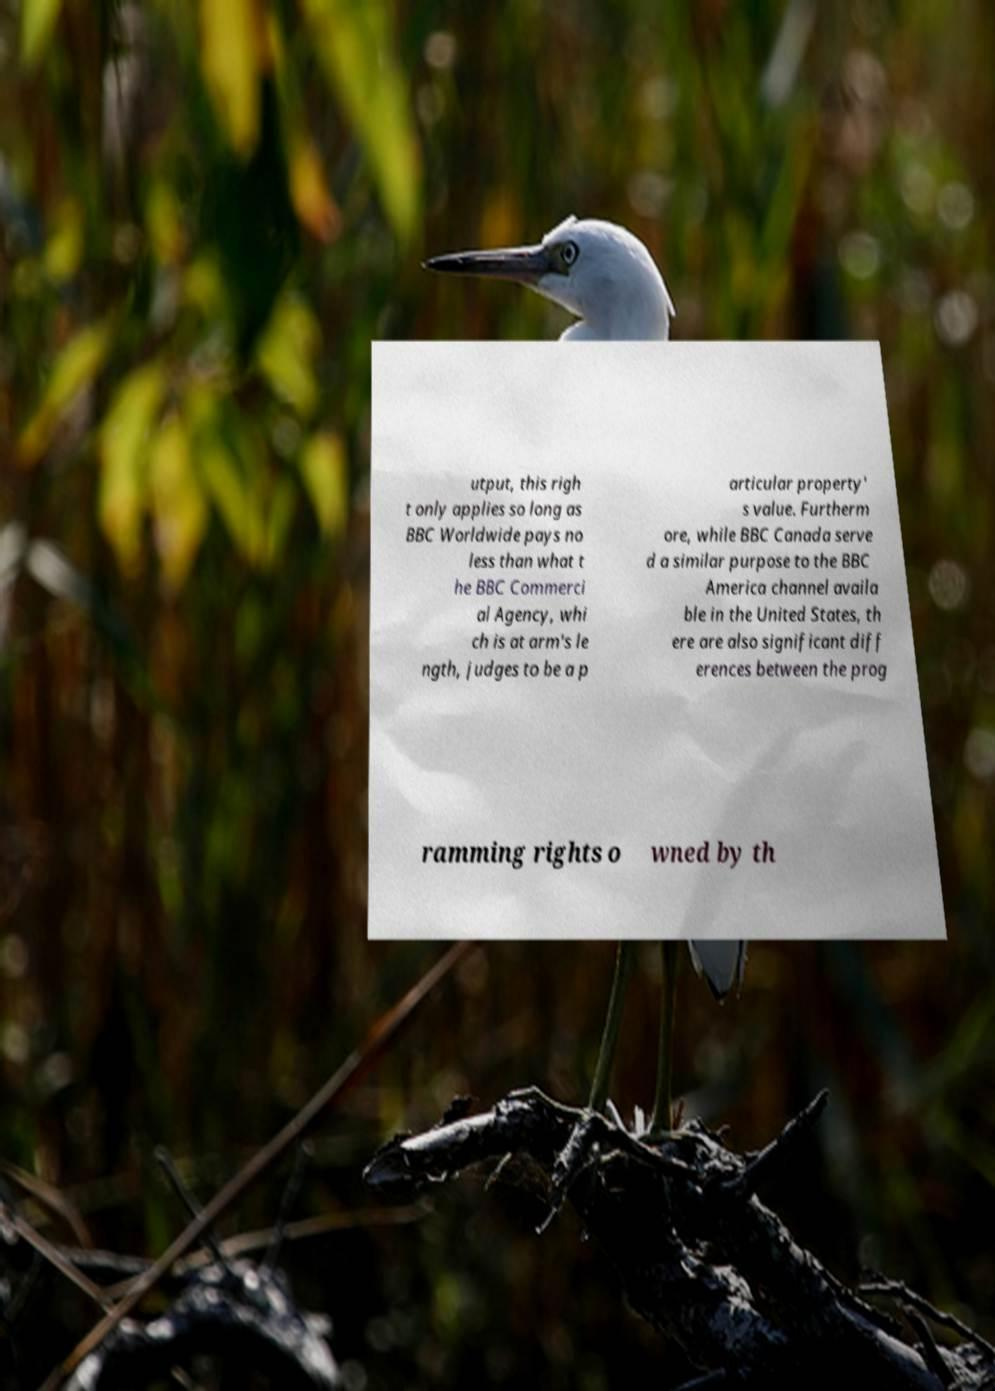Please read and relay the text visible in this image. What does it say? utput, this righ t only applies so long as BBC Worldwide pays no less than what t he BBC Commerci al Agency, whi ch is at arm's le ngth, judges to be a p articular property' s value. Furtherm ore, while BBC Canada serve d a similar purpose to the BBC America channel availa ble in the United States, th ere are also significant diff erences between the prog ramming rights o wned by th 